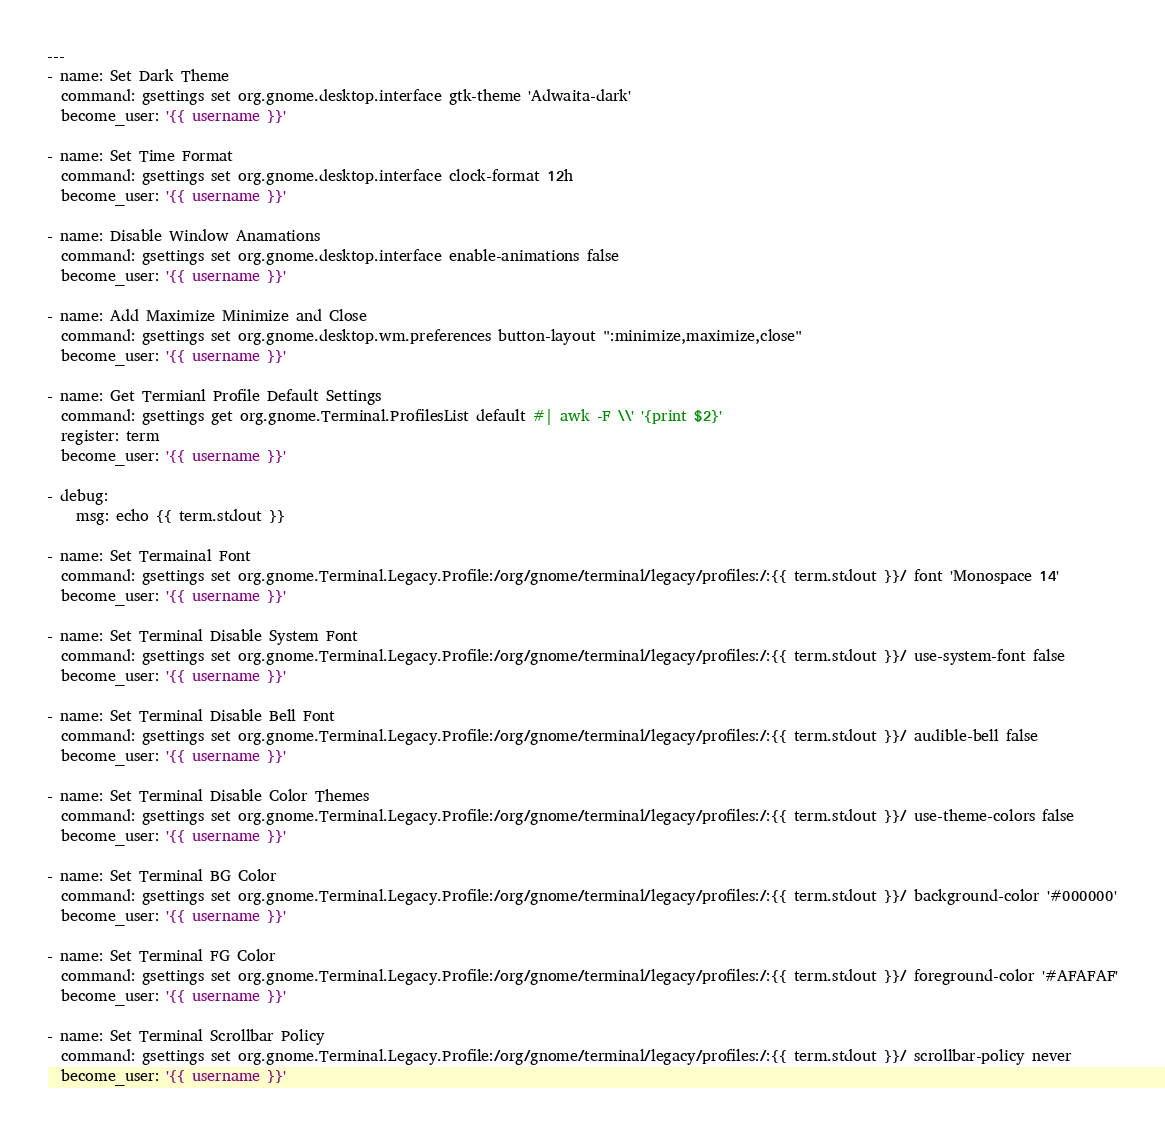<code> <loc_0><loc_0><loc_500><loc_500><_YAML_>---
- name: Set Dark Theme
  command: gsettings set org.gnome.desktop.interface gtk-theme 'Adwaita-dark'
  become_user: '{{ username }}'

- name: Set Time Format
  command: gsettings set org.gnome.desktop.interface clock-format 12h
  become_user: '{{ username }}'

- name: Disable Window Anamations
  command: gsettings set org.gnome.desktop.interface enable-animations false
  become_user: '{{ username }}'

- name: Add Maximize Minimize and Close
  command: gsettings set org.gnome.desktop.wm.preferences button-layout ":minimize,maximize,close"
  become_user: '{{ username }}'

- name: Get Termianl Profile Default Settings
  command: gsettings get org.gnome.Terminal.ProfilesList default #| awk -F \\' '{print $2}'
  register: term
  become_user: '{{ username }}'

- debug:
    msg: echo {{ term.stdout }}

- name: Set Termainal Font
  command: gsettings set org.gnome.Terminal.Legacy.Profile:/org/gnome/terminal/legacy/profiles:/:{{ term.stdout }}/ font 'Monospace 14'
  become_user: '{{ username }}'

- name: Set Terminal Disable System Font
  command: gsettings set org.gnome.Terminal.Legacy.Profile:/org/gnome/terminal/legacy/profiles:/:{{ term.stdout }}/ use-system-font false
  become_user: '{{ username }}'

- name: Set Terminal Disable Bell Font
  command: gsettings set org.gnome.Terminal.Legacy.Profile:/org/gnome/terminal/legacy/profiles:/:{{ term.stdout }}/ audible-bell false
  become_user: '{{ username }}'

- name: Set Terminal Disable Color Themes
  command: gsettings set org.gnome.Terminal.Legacy.Profile:/org/gnome/terminal/legacy/profiles:/:{{ term.stdout }}/ use-theme-colors false
  become_user: '{{ username }}'

- name: Set Terminal BG Color
  command: gsettings set org.gnome.Terminal.Legacy.Profile:/org/gnome/terminal/legacy/profiles:/:{{ term.stdout }}/ background-color '#000000'
  become_user: '{{ username }}'

- name: Set Terminal FG Color
  command: gsettings set org.gnome.Terminal.Legacy.Profile:/org/gnome/terminal/legacy/profiles:/:{{ term.stdout }}/ foreground-color '#AFAFAF'
  become_user: '{{ username }}'

- name: Set Terminal Scrollbar Policy
  command: gsettings set org.gnome.Terminal.Legacy.Profile:/org/gnome/terminal/legacy/profiles:/:{{ term.stdout }}/ scrollbar-policy never
  become_user: '{{ username }}'
</code> 